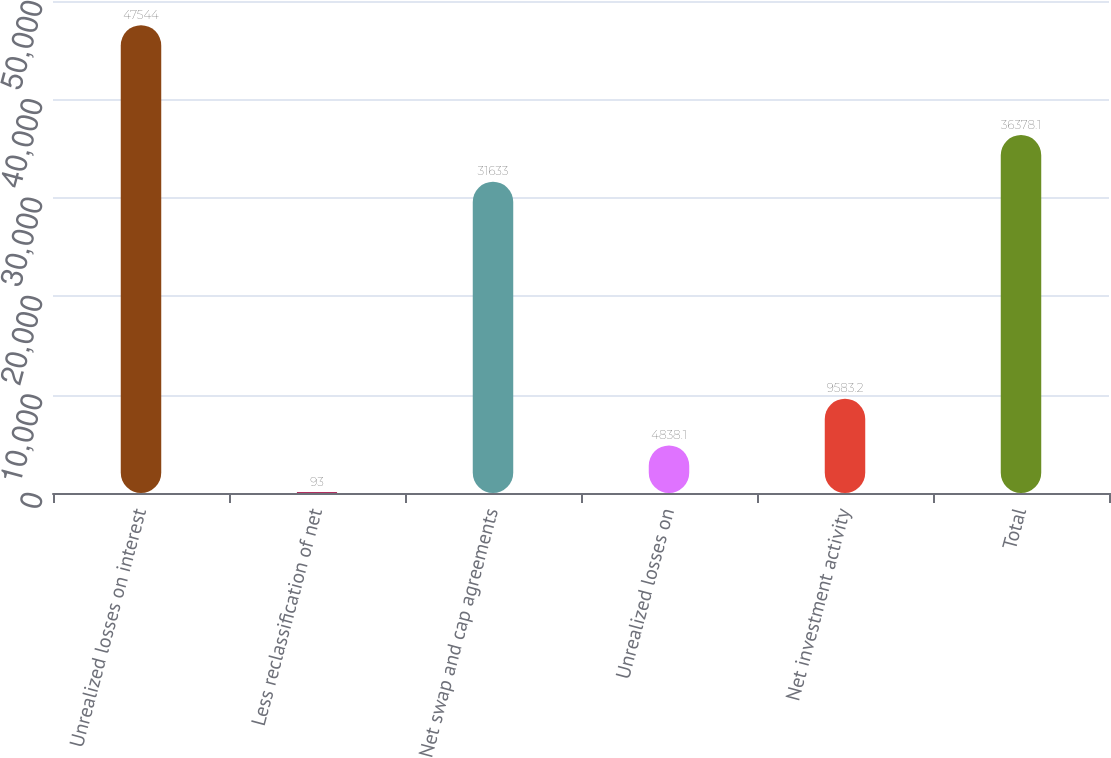<chart> <loc_0><loc_0><loc_500><loc_500><bar_chart><fcel>Unrealized losses on interest<fcel>Less reclassification of net<fcel>Net swap and cap agreements<fcel>Unrealized losses on<fcel>Net investment activity<fcel>Total<nl><fcel>47544<fcel>93<fcel>31633<fcel>4838.1<fcel>9583.2<fcel>36378.1<nl></chart> 